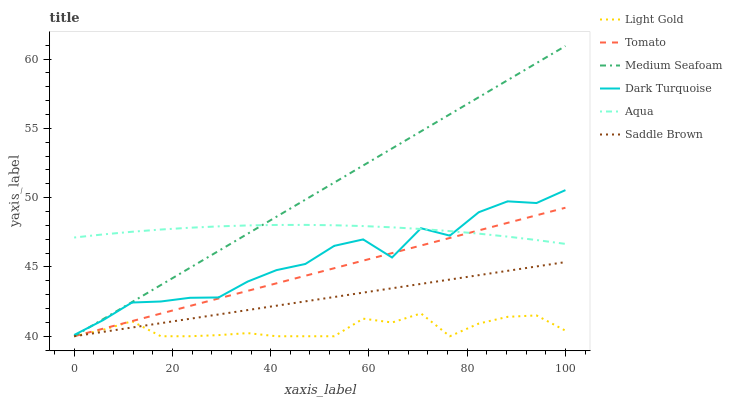Does Light Gold have the minimum area under the curve?
Answer yes or no. Yes. Does Medium Seafoam have the maximum area under the curve?
Answer yes or no. Yes. Does Dark Turquoise have the minimum area under the curve?
Answer yes or no. No. Does Dark Turquoise have the maximum area under the curve?
Answer yes or no. No. Is Saddle Brown the smoothest?
Answer yes or no. Yes. Is Dark Turquoise the roughest?
Answer yes or no. Yes. Is Aqua the smoothest?
Answer yes or no. No. Is Aqua the roughest?
Answer yes or no. No. Does Tomato have the lowest value?
Answer yes or no. Yes. Does Dark Turquoise have the lowest value?
Answer yes or no. No. Does Medium Seafoam have the highest value?
Answer yes or no. Yes. Does Dark Turquoise have the highest value?
Answer yes or no. No. Is Saddle Brown less than Dark Turquoise?
Answer yes or no. Yes. Is Dark Turquoise greater than Light Gold?
Answer yes or no. Yes. Does Light Gold intersect Tomato?
Answer yes or no. Yes. Is Light Gold less than Tomato?
Answer yes or no. No. Is Light Gold greater than Tomato?
Answer yes or no. No. Does Saddle Brown intersect Dark Turquoise?
Answer yes or no. No. 